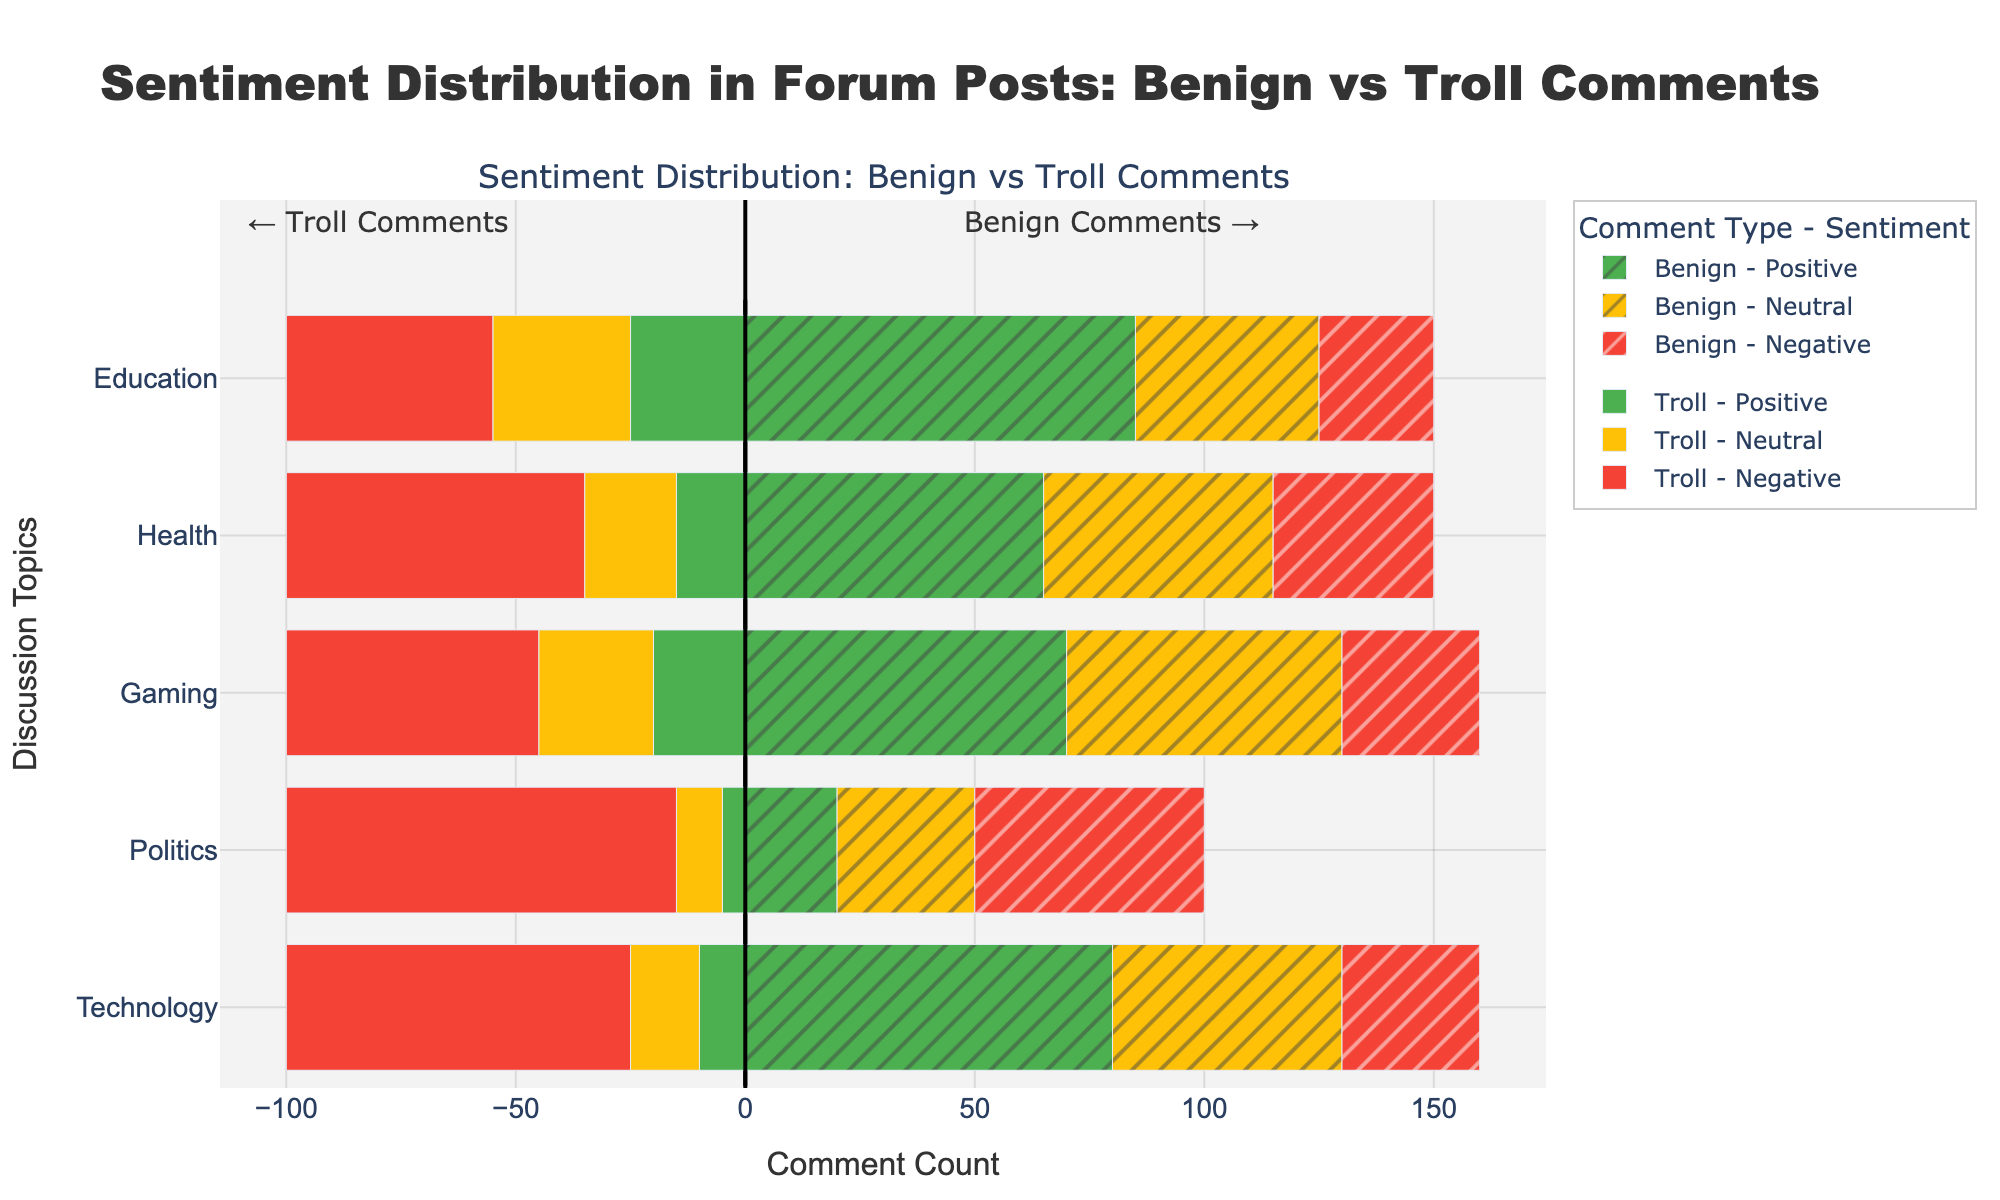Which topic has the highest number of troll comments? From the figure, observe the bars representing troll comments towards the left. Look for the longest bar. The Technology topic has the longest negative bar, indicating the highest troll comments.
Answer: Technology How many more neutral benign comments are there in Health compared to Technology? Examine the bars representing neutral benign comments (yellow and patterned). Health has 50 neutral benign comments, and Technology has 30. The difference is calculated as 50 - 30.
Answer: 20 Which sentiment has the smallest number of troll comments overall? Sum up the troll comments for each sentiment across all topics. Positive: 10+5+20+15+25 = 75, Neutral: 15+10+25+20+30 = 100, Negative: 75+85+55+65+45 = 325. The positive sentiment has the smallest number of troll comments at 75.
Answer: Positive Compare the number of negative benign comments in Politics and Gaming. Which one has more? Look at the bars for negative benign comments (red and patterned) in Politics and Gaming. Politics has 50 negative benign comments, Gaming has 30. Politics has more.
Answer: Politics What is the total number of benign comments in the Education topic? Add the benign comments for each sentiment in the Education topic: Positive (85) + Neutral (40) + Negative (25). 85 + 40 + 25 = 150.
Answer: 150 How does the number of neutral troll comments in Gaming compare to those in Health? Examine the bars for neutral troll comments (yellow) in both topics. Gaming has 25, and Health has 20. Gaming has more neutral troll comments by 5.
Answer: Gaming What is the percentage of negative troll comments out of the total troll comments in Politics? Calculate the total troll comments in Politics: Positive (5) + Neutral (10) + Negative (85) = 100, then find the percentage of negative comments: (85/100) * 100 = 85%.
Answer: 85% Which topic has the most evenly distributed sentiment for benign comments? Look for a topic where the benign bars (patterned) for positive, neutral, and negative sentiments are closest in length. Education has the bars for benign comments being 85, 40, and 25, which are fairly balanced compared to other topics.
Answer: Education 